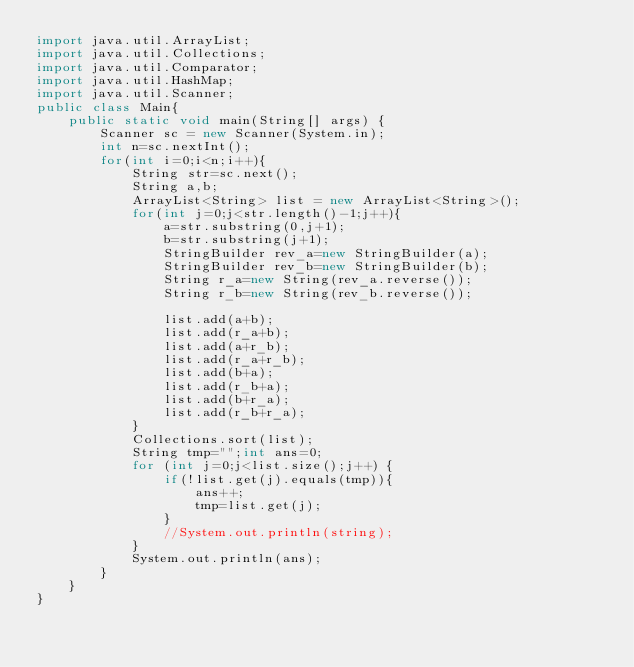<code> <loc_0><loc_0><loc_500><loc_500><_Java_>import java.util.ArrayList;
import java.util.Collections;
import java.util.Comparator;
import java.util.HashMap;
import java.util.Scanner;
public class Main{
	public static void main(String[] args) {
		Scanner sc = new Scanner(System.in);
		int n=sc.nextInt();
		for(int i=0;i<n;i++){
			String str=sc.next();
			String a,b;
			ArrayList<String> list = new ArrayList<String>();
			for(int j=0;j<str.length()-1;j++){
				a=str.substring(0,j+1);
				b=str.substring(j+1);
				StringBuilder rev_a=new StringBuilder(a);
				StringBuilder rev_b=new StringBuilder(b);
				String r_a=new String(rev_a.reverse());
				String r_b=new String(rev_b.reverse());

				list.add(a+b);
				list.add(r_a+b);
				list.add(a+r_b);
				list.add(r_a+r_b);
				list.add(b+a);
				list.add(r_b+a);
				list.add(b+r_a);
				list.add(r_b+r_a);
			}	
			Collections.sort(list);
			String tmp="";int ans=0;
			for (int j=0;j<list.size();j++) {
				if(!list.get(j).equals(tmp)){
					ans++;
					tmp=list.get(j);
				}
				//System.out.println(string);
			}
			System.out.println(ans);
		}
	}
}</code> 